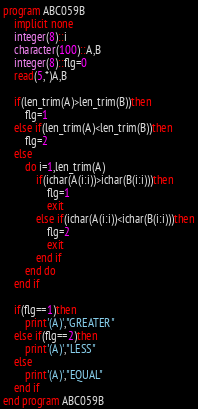Convert code to text. <code><loc_0><loc_0><loc_500><loc_500><_FORTRAN_>program ABC059B
    implicit none
    integer(8)::i
    character(100)::A,B
    integer(8)::flg=0
    read(5,*)A,B

    if(len_trim(A)>len_trim(B))then
        flg=1
    else if(len_trim(A)<len_trim(B))then
        flg=2
    else
        do i=1,len_trim(A)
            if(ichar(A(i:i))>ichar(B(i:i)))then
                flg=1
                exit
            else if(ichar(A(i:i))<ichar(B(i:i)))then
                flg=2
                exit
            end if
        end do
    end if

    if(flg==1)then
        print'(A)',"GREATER"
    else if(flg==2)then
        print'(A)',"LESS"
    else
        print'(A)',"EQUAL"
    end if
end program ABC059B</code> 